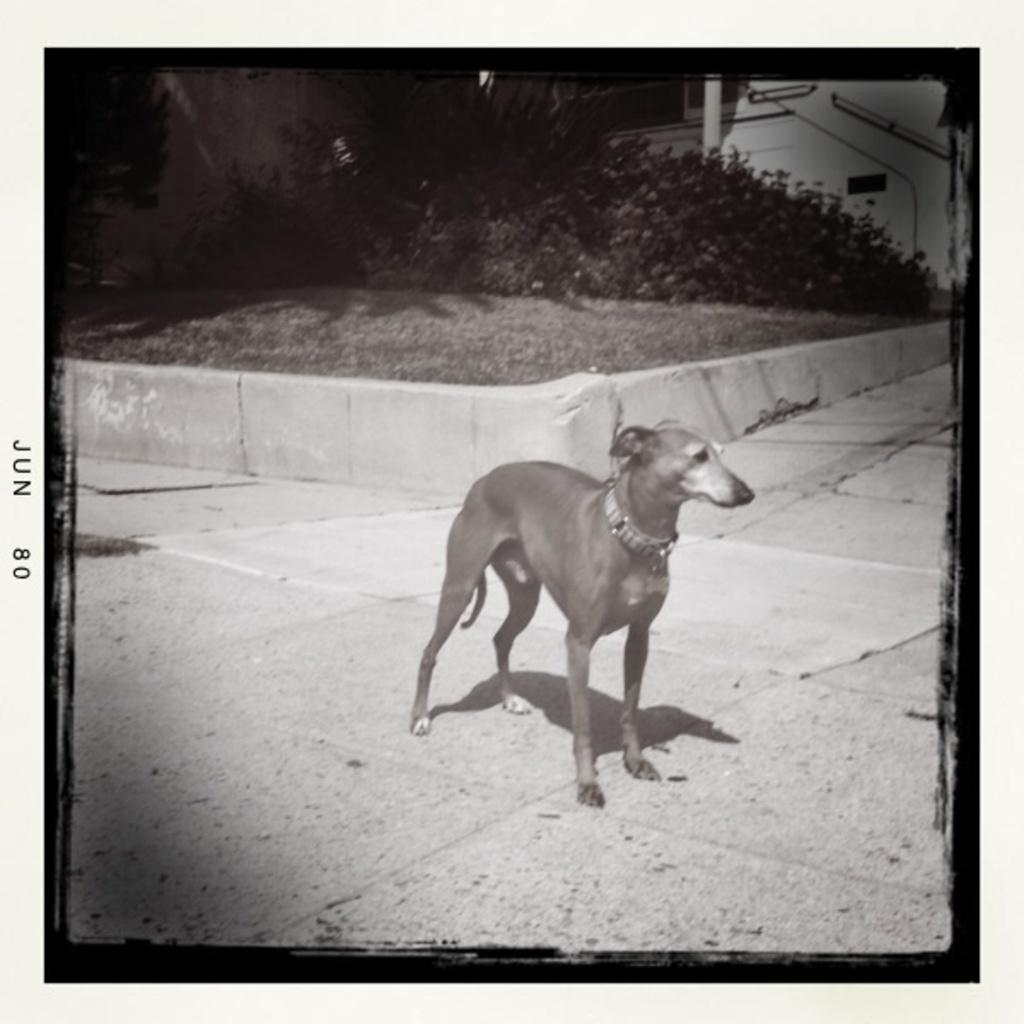What is the color scheme of the image? The image is black and white. What animal can be seen in the image? There is a dog in the image. Where is the dog positioned in the image? The dog is standing on the floor. What type of natural elements can be seen in the background of the image? There are trees, plants, and pillars in the background of the image. What is the dog's income in the image? Dogs do not have income, so this question cannot be answered. How many fangs does the dog have in the image? The image is black and white, so it is difficult to determine the number of fangs the dog has. However, dogs typically have 42 teeth, with 12 of them being incisors, 4 of them being canines (or fangs), 16 of them being premolars, and 10 of them being molars. 